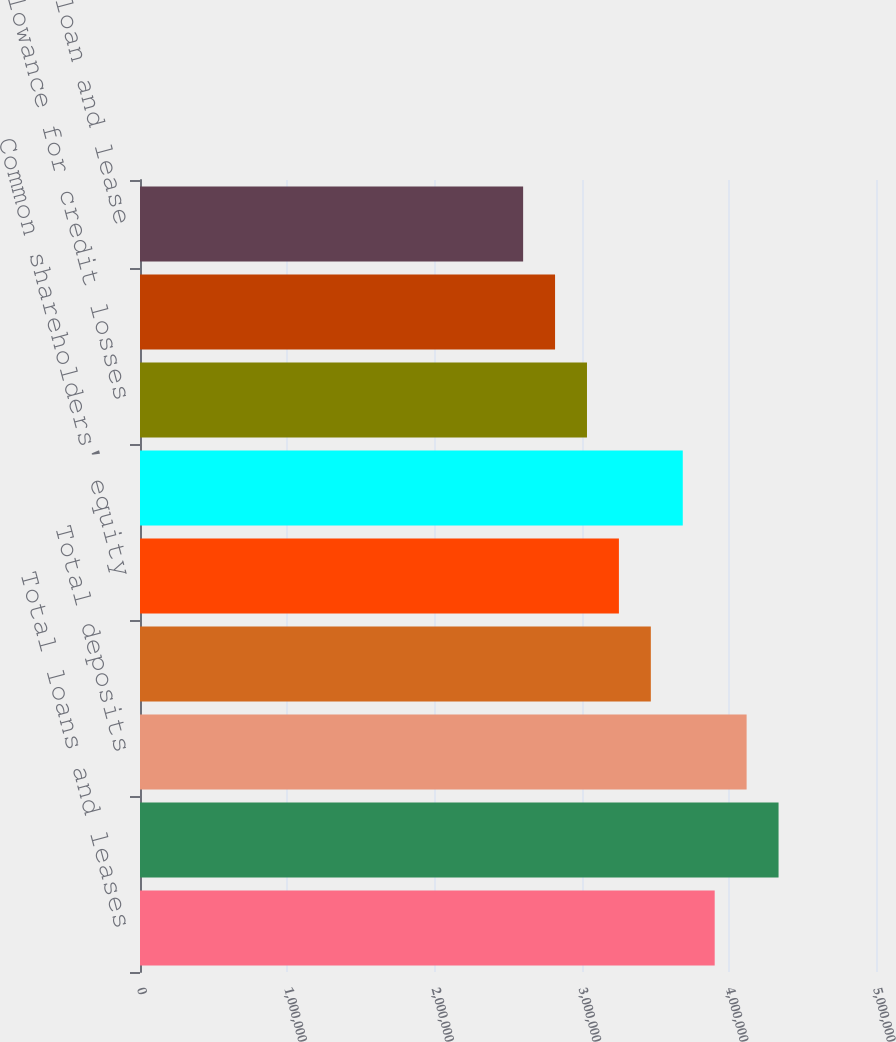Convert chart to OTSL. <chart><loc_0><loc_0><loc_500><loc_500><bar_chart><fcel>Total loans and leases<fcel>Total assets<fcel>Total deposits<fcel>Long-term debt<fcel>Common shareholders' equity<fcel>Total shareholders' equity<fcel>Allowance for credit losses<fcel>Nonperforming loans leases and<fcel>Allowance for loan and lease<nl><fcel>3.90419e+06<fcel>4.33798e+06<fcel>4.12109e+06<fcel>3.47039e+06<fcel>3.25349e+06<fcel>3.68729e+06<fcel>3.03659e+06<fcel>2.81969e+06<fcel>2.60279e+06<nl></chart> 